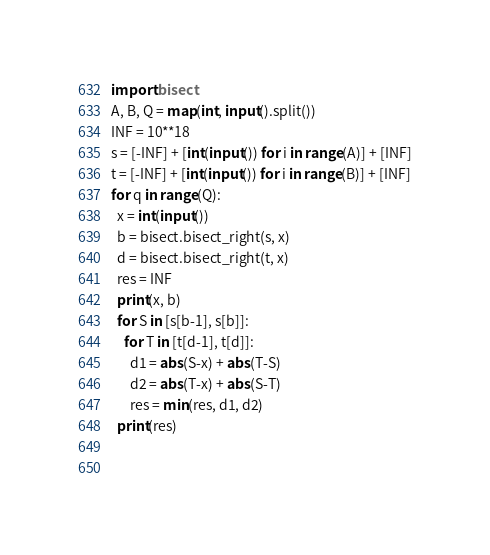<code> <loc_0><loc_0><loc_500><loc_500><_Python_>import bisect
A, B, Q = map(int, input().split())
INF = 10**18
s = [-INF] + [int(input()) for i in range(A)] + [INF]
t = [-INF] + [int(input()) for i in range(B)] + [INF]
for q in range(Q):
  x = int(input())
  b = bisect.bisect_right(s, x)
  d = bisect.bisect_right(t, x)
  res = INF
  print(x, b)
  for S in [s[b-1], s[b]]:
    for T in [t[d-1], t[d]]:
      d1 = abs(S-x) + abs(T-S)
      d2 = abs(T-x) + abs(S-T)
      res = min(res, d1, d2)
  print(res)
    
  </code> 